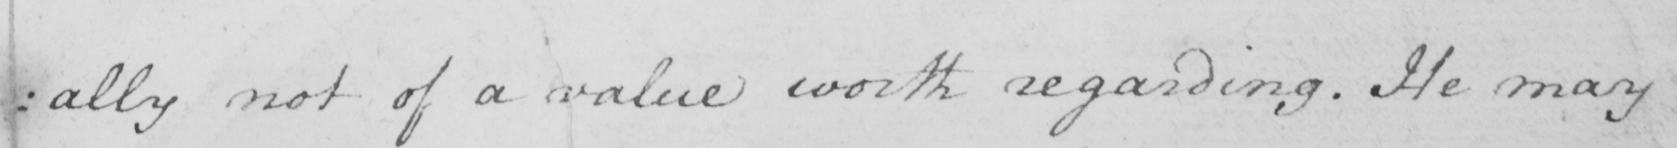Please provide the text content of this handwritten line. : ally not of a value worth regarding . He may 